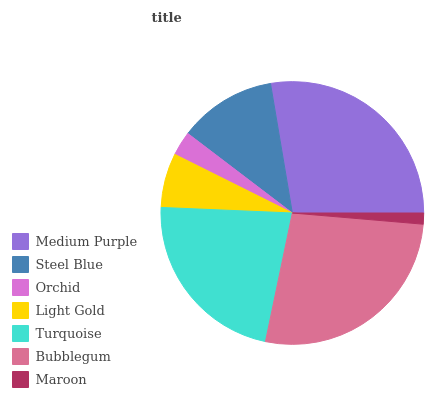Is Maroon the minimum?
Answer yes or no. Yes. Is Medium Purple the maximum?
Answer yes or no. Yes. Is Steel Blue the minimum?
Answer yes or no. No. Is Steel Blue the maximum?
Answer yes or no. No. Is Medium Purple greater than Steel Blue?
Answer yes or no. Yes. Is Steel Blue less than Medium Purple?
Answer yes or no. Yes. Is Steel Blue greater than Medium Purple?
Answer yes or no. No. Is Medium Purple less than Steel Blue?
Answer yes or no. No. Is Steel Blue the high median?
Answer yes or no. Yes. Is Steel Blue the low median?
Answer yes or no. Yes. Is Bubblegum the high median?
Answer yes or no. No. Is Medium Purple the low median?
Answer yes or no. No. 